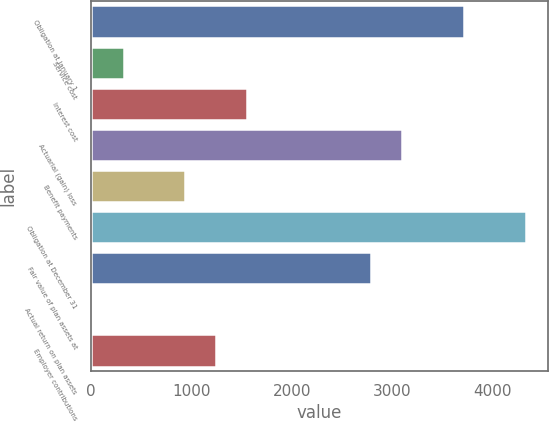Convert chart. <chart><loc_0><loc_0><loc_500><loc_500><bar_chart><fcel>Obligation at January 1<fcel>Service cost<fcel>Interest cost<fcel>Actuarial (gain) loss<fcel>Benefit payments<fcel>Obligation at December 31<fcel>Fair value of plan assets at<fcel>Actual return on plan assets<fcel>Employer contributions<nl><fcel>3713<fcel>325<fcel>1557<fcel>3097<fcel>941<fcel>4329<fcel>2789<fcel>17<fcel>1249<nl></chart> 